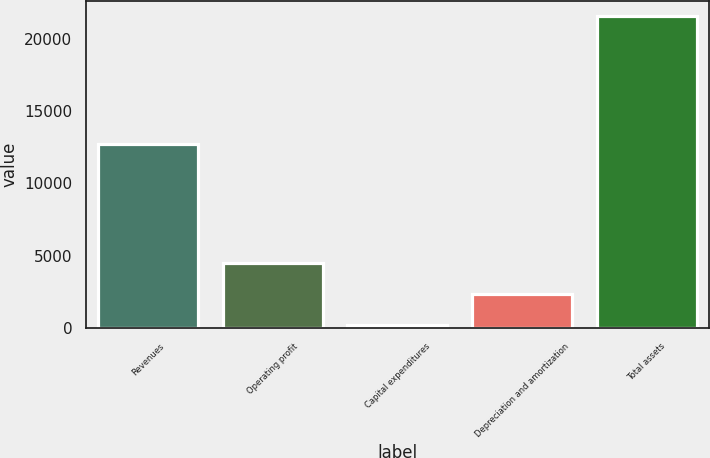Convert chart to OTSL. <chart><loc_0><loc_0><loc_500><loc_500><bar_chart><fcel>Revenues<fcel>Operating profit<fcel>Capital expenditures<fcel>Depreciation and amortization<fcel>Total assets<nl><fcel>12712<fcel>4506.4<fcel>250<fcel>2378.2<fcel>21532<nl></chart> 